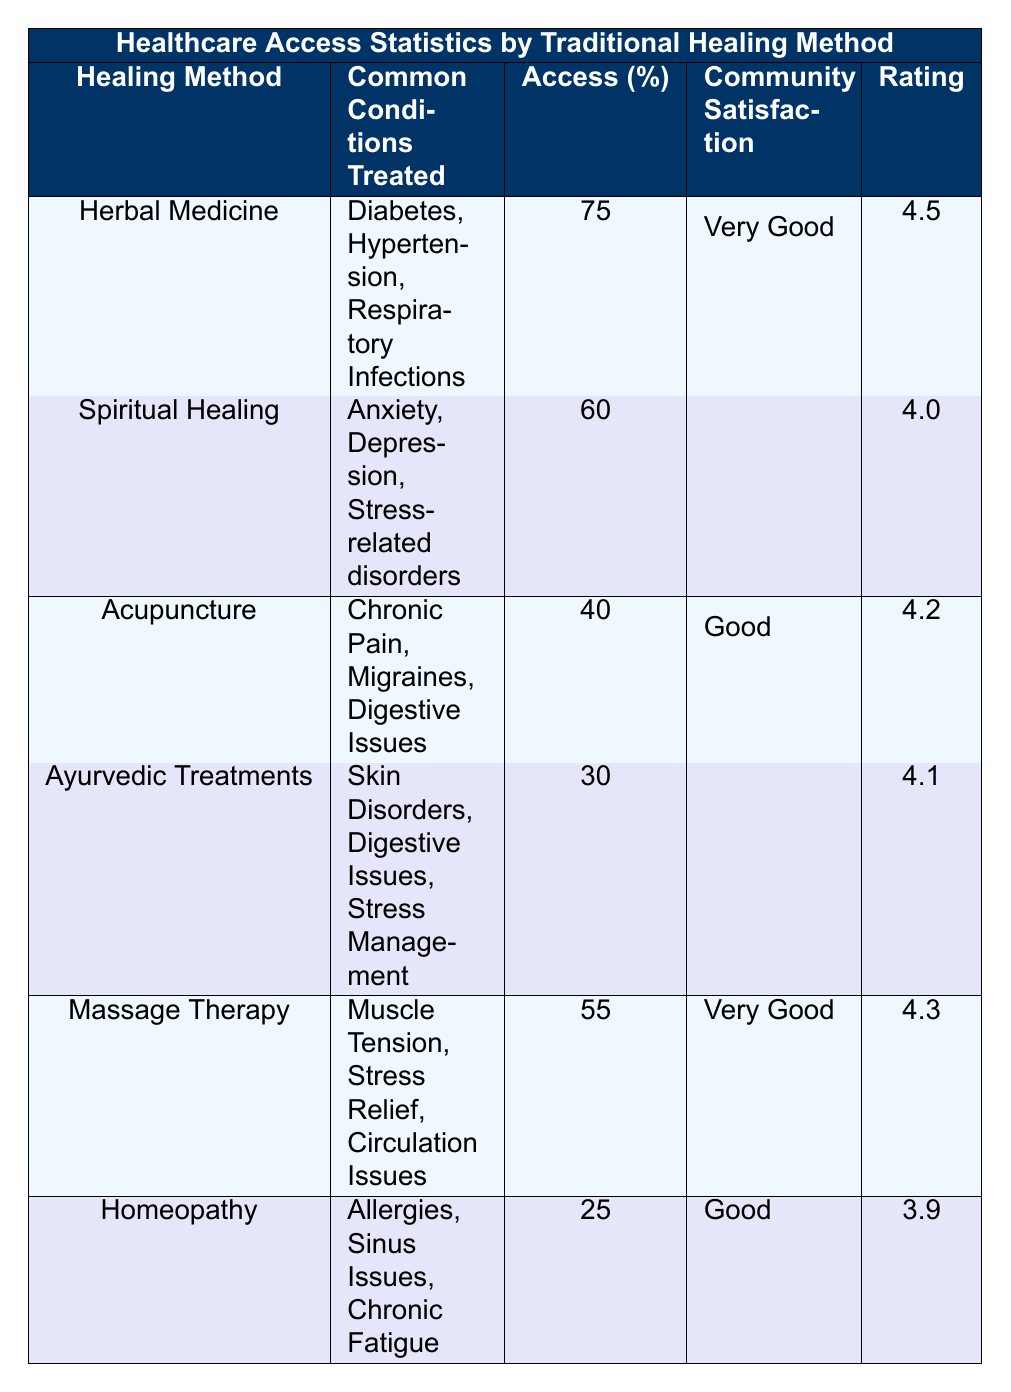What is the access percentage for Herbal Medicine? The access percentage for Herbal Medicine is listed directly in the table under the "Access (%)" column for that particular method. It shows 75%.
Answer: 75 Which healing method has the highest community satisfaction rating? By examining the "Community Satisfaction" column in the table, the highest rating is 4.5, which corresponds to Herbal Medicine.
Answer: Herbal Medicine Are there more healing methods with a "Very Good" satisfaction rating than those with "Good"? There are three methods (Herbal Medicine, Massage Therapy) with a "Very Good" rating and two methods (Acupuncture, Homeopathy) with a "Good" rating. Thus, the answer is yes.
Answer: Yes What is the average access percentage for all healing methods listed? To calculate the average, sum the access percentages (75 + 60 + 40 + 30 + 55 + 25 = 285) and divide by the number of methods (6), which gives 285/6 = 47.5.
Answer: 47.5 Is Spiritual Healing effective for treating Stress-related disorders? Spiritual Healing is specifically mentioned as treating Anxiety, Depression, and Stress-related disorders, indicating it is effective for the latter condition.
Answer: Yes Which traditional healing method has the lowest access percentage? By reviewing the "Access (%)" column, Homeopathy shows the lowest value at 25%.
Answer: Homeopathy What is the combined satisfaction rating for Acupuncture and Ayurvedic Treatments? To obtain the combined satisfaction rating, we need to add the satisfaction ratings for Acupuncture (4.2) and Ayurvedic Treatments (4.1). This results in 4.2 + 4.1 = 8.3.
Answer: 8.3 Does Massage Therapy have a higher access percentage compared to Homeopathy? The table displays an access percentage of 55% for Massage Therapy and 25% for Homeopathy. Comparing these values shows that Massage Therapy has a higher percentage.
Answer: Yes What condition does Herbal Medicine treat that is not mentioned for Homeopathy? Homeopathy includes Allergies, Sinus Issues, and Chronic Fatigue, while Herbal Medicine treats Diabetes, which is not in Homeopathy's list.
Answer: Diabetes 